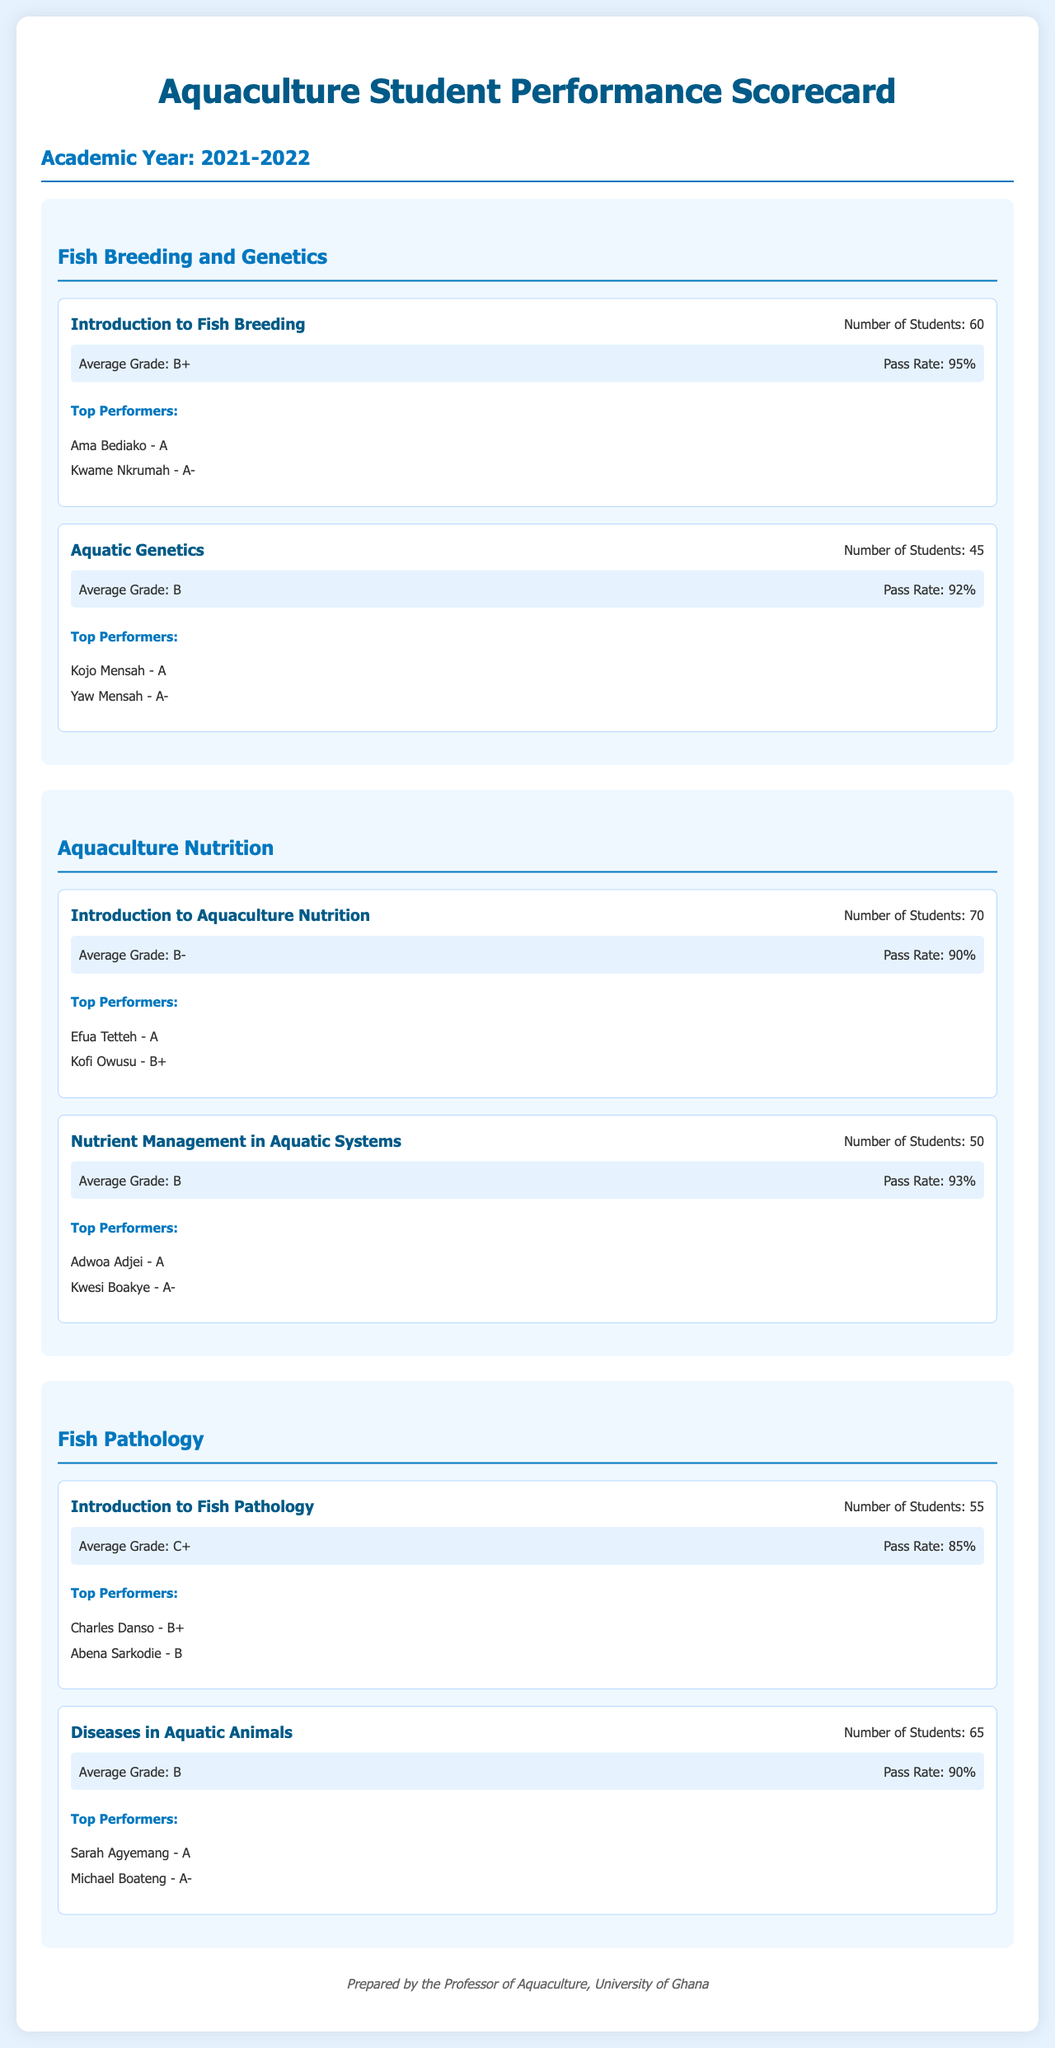What is the average grade for Introduction to Fish Breeding? The average grade is stated in the course stats for Introduction to Fish Breeding.
Answer: B+ How many students were enrolled in Aquatic Genetics? The document provides the number of students enrolled in the course Aquatic Genetics.
Answer: 45 Who are the top performers in Nutrient Management in Aquatic Systems? The top performers are listed in the top performers section for the course Nutrient Management in Aquatic Systems.
Answer: Adwoa Adjei - A, Kwesi Boakye - A- What is the pass rate for the course Diseases in Aquatic Animals? The pass rate is mentioned under the course stats for Diseases in Aquatic Animals.
Answer: 90% Which department has the highest average grade based on the courses listed? This requires comparison of average grades across departments. Fish Breeding and Genetics has the highest average grade (B+).
Answer: Fish Breeding and Genetics What is the total number of students across all courses in the Fish Pathology department? The total is calculated by adding the number of students for each course in the Fish Pathology department.
Answer: 120 Who scored the top grade in the course Introduction to Aquaculture Nutrition? This information can be found in the top performers section of that course.
Answer: Efua Tetteh - A What was the overall pass rate for the Aquaculture Nutrition department? The overall pass rate can be inferred from individual course pass rates; the average is approximately 91.5%.
Answer: Approximately 91.5% How many courses are listed under the Fish Breeding and Genetics department? The number of courses is stated in the department section.
Answer: 2 